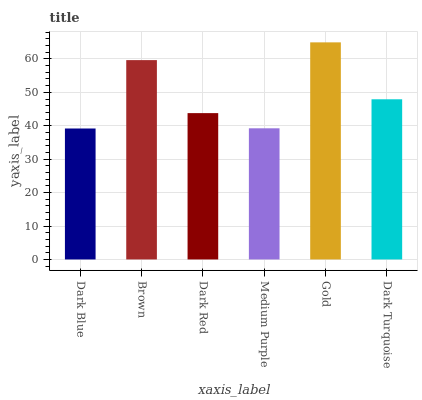Is Dark Blue the minimum?
Answer yes or no. Yes. Is Gold the maximum?
Answer yes or no. Yes. Is Brown the minimum?
Answer yes or no. No. Is Brown the maximum?
Answer yes or no. No. Is Brown greater than Dark Blue?
Answer yes or no. Yes. Is Dark Blue less than Brown?
Answer yes or no. Yes. Is Dark Blue greater than Brown?
Answer yes or no. No. Is Brown less than Dark Blue?
Answer yes or no. No. Is Dark Turquoise the high median?
Answer yes or no. Yes. Is Dark Red the low median?
Answer yes or no. Yes. Is Gold the high median?
Answer yes or no. No. Is Dark Blue the low median?
Answer yes or no. No. 